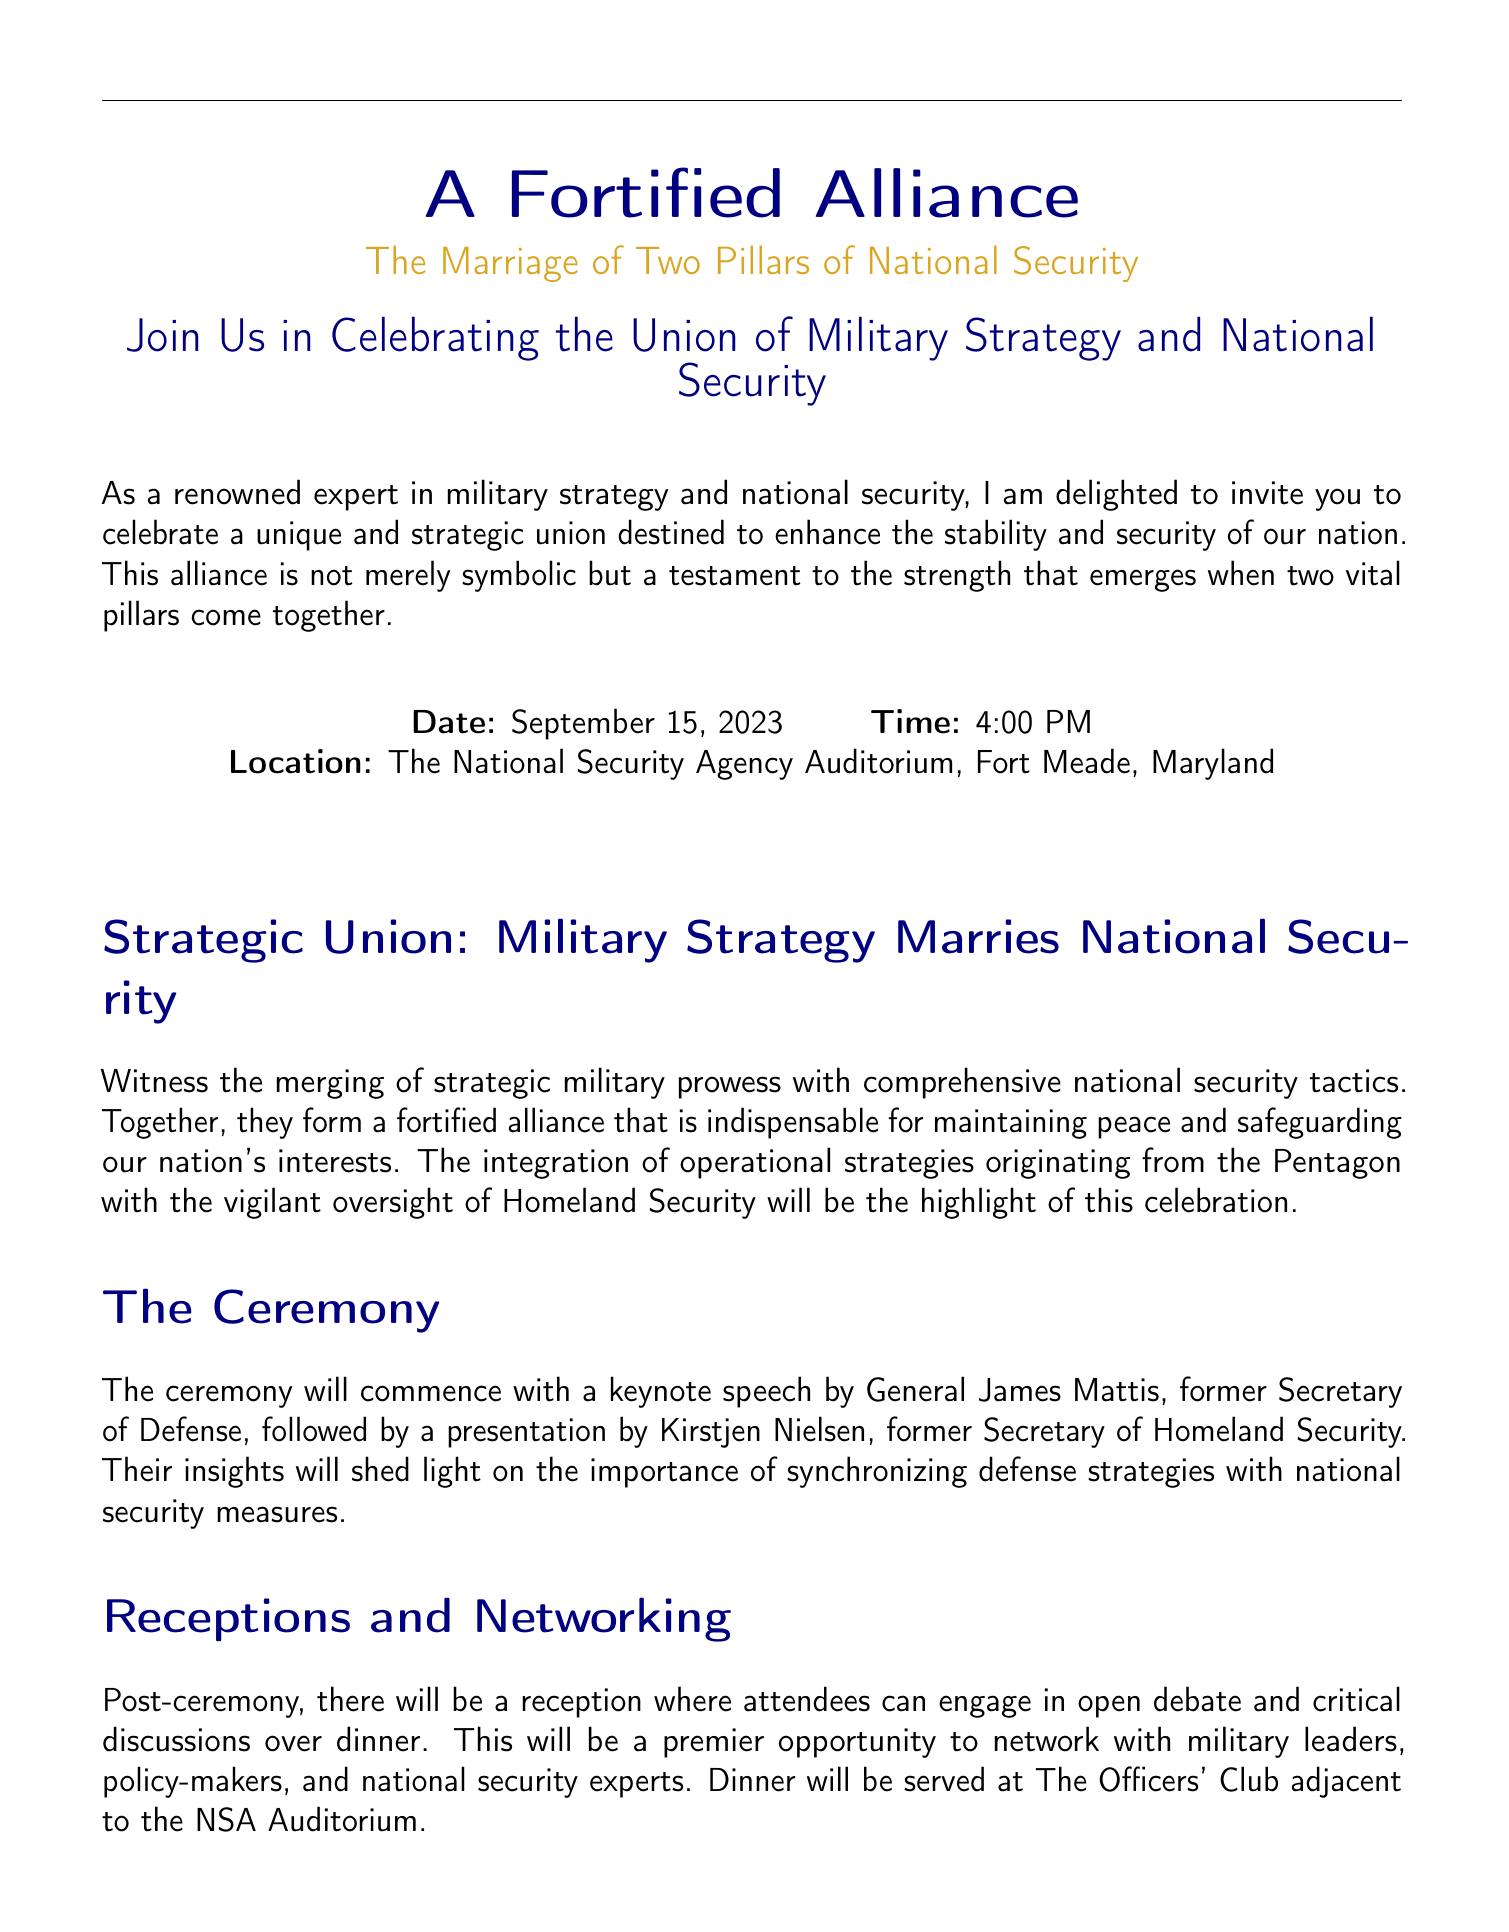What is the date of the event? The date of the event is mentioned clearly in the invitation under the date section.
Answer: September 15, 2023 Who is the keynote speaker at the ceremony? The keynote speaker is listed in the section describing the ceremony's events.
Answer: General James Mattis Where is the location of the event? The location of the event is specified in the center of the document, providing the venue name and place.
Answer: The National Security Agency Auditorium, Fort Meade, Maryland What type of activity is titled 'The Power of Unity'? This title is mentioned in the section describing the symbolic activities planned during the event.
Answer: Demonstration What time does the event start? The starting time for the event is stated next to the date in the invitation.
Answer: 4:00 PM What opportunity is provided after the ceremony? The invitation mentions what attendees can engage in post-ceremony, highlighting the nature of interactions.
Answer: Reception Who will present after the keynote speech? The individual following the keynote speaker is referenced in the ceremony section.
Answer: Kirstjen Nielsen What is the theme of the wedding invitation? The central theme is described at the beginning of the document, connecting to military and national security concepts.
Answer: A Fortified Alliance 